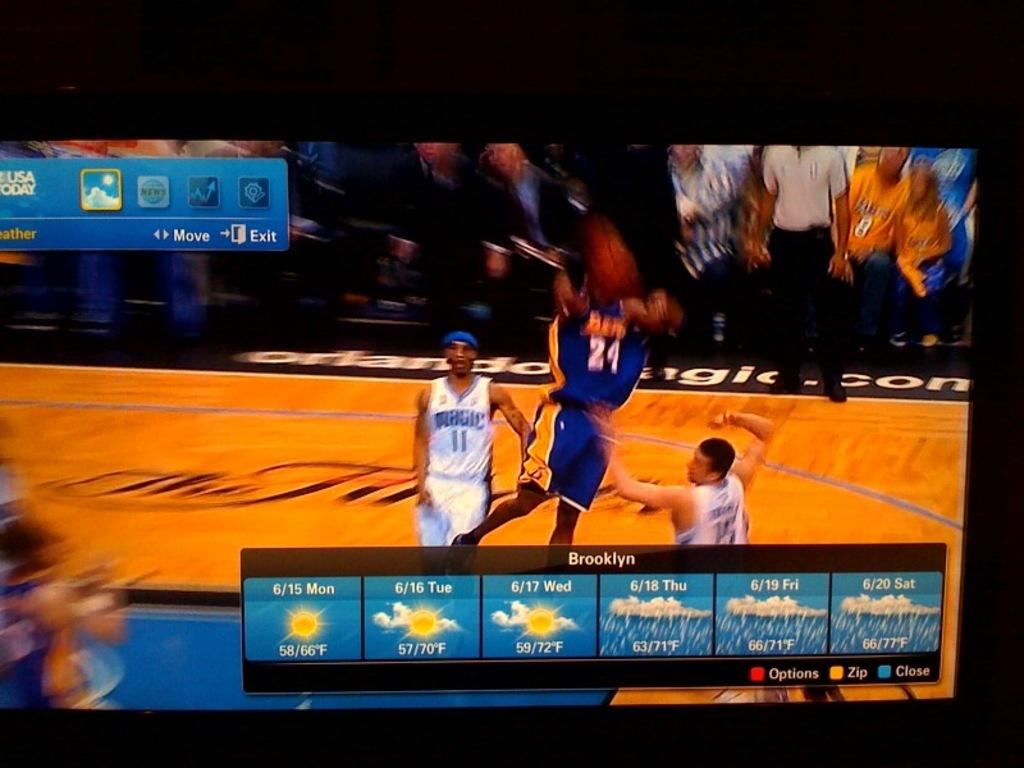Provide a one-sentence caption for the provided image. A basketball game plays on a TV as the weather for Brooklyn is displayed in the foreground. 